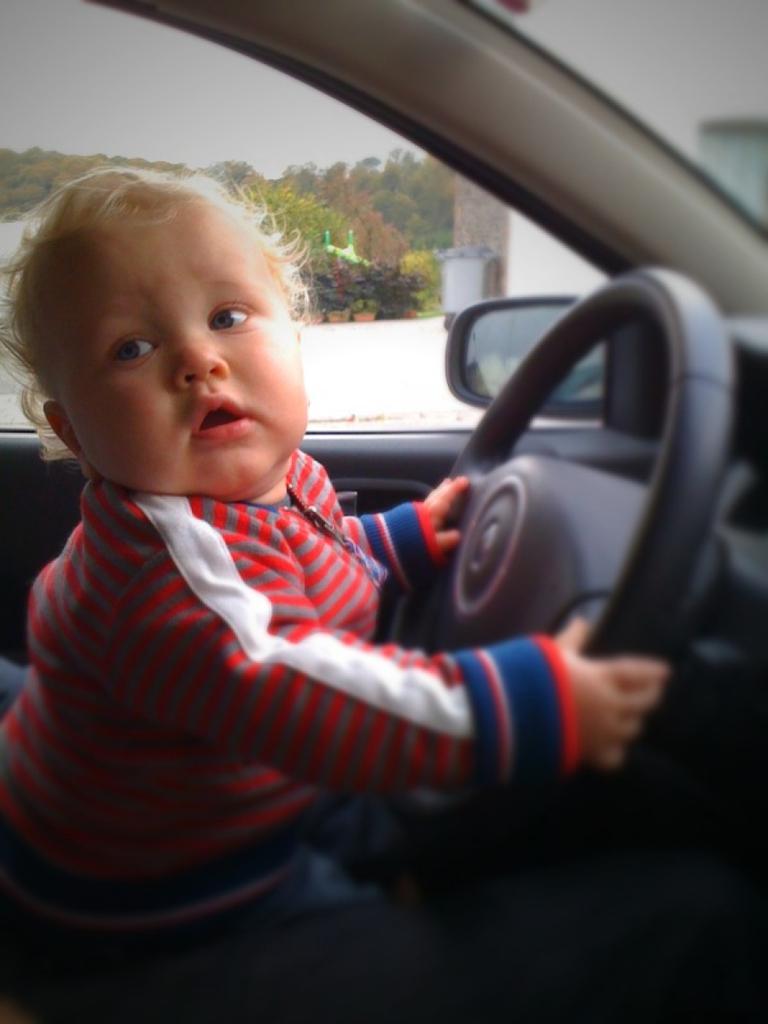Can you describe this image briefly? In this image I can see the child sitting in the car and holding steering with his hands. At the outside of the car there is a building,sky,and the trees. 